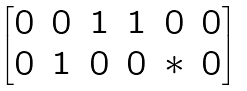Convert formula to latex. <formula><loc_0><loc_0><loc_500><loc_500>\begin{bmatrix} 0 & 0 & 1 & 1 & 0 & 0 \\ 0 & 1 & 0 & 0 & * & 0 \end{bmatrix}</formula> 